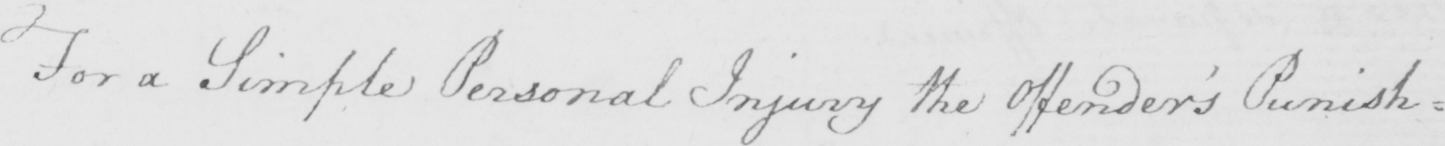Please provide the text content of this handwritten line. For a Simple Personal Injury the Offender ' s Punish : 